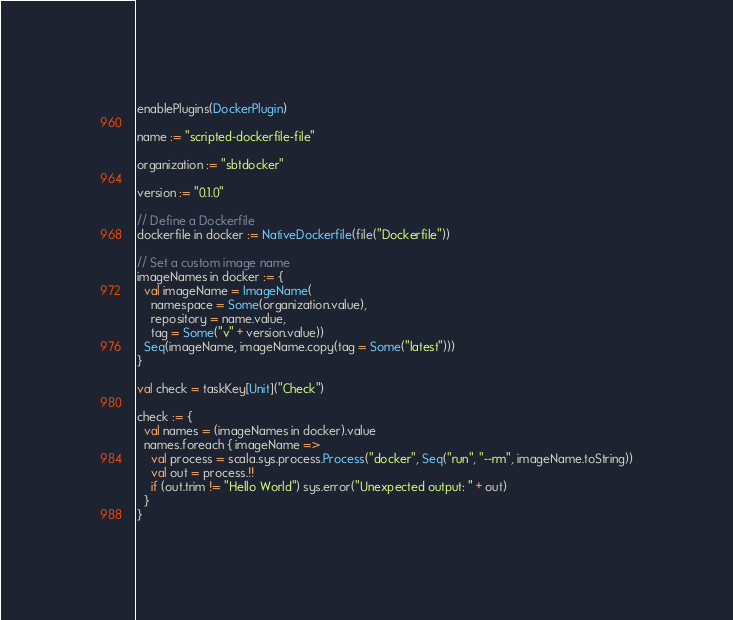<code> <loc_0><loc_0><loc_500><loc_500><_Scala_>enablePlugins(DockerPlugin)

name := "scripted-dockerfile-file"

organization := "sbtdocker"

version := "0.1.0"

// Define a Dockerfile
dockerfile in docker := NativeDockerfile(file("Dockerfile"))

// Set a custom image name
imageNames in docker := {
  val imageName = ImageName(
    namespace = Some(organization.value),
    repository = name.value,
    tag = Some("v" + version.value))
  Seq(imageName, imageName.copy(tag = Some("latest")))
}

val check = taskKey[Unit]("Check")

check := {
  val names = (imageNames in docker).value
  names.foreach { imageName =>
    val process = scala.sys.process.Process("docker", Seq("run", "--rm", imageName.toString))
    val out = process.!!
    if (out.trim != "Hello World") sys.error("Unexpected output: " + out)
  }
}
</code> 